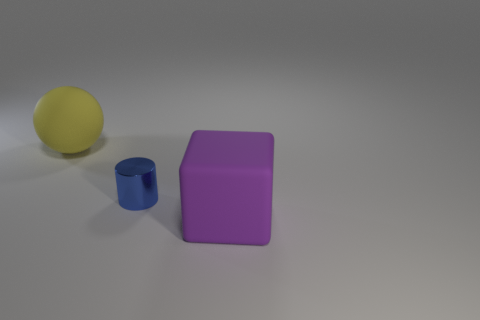Add 1 big purple objects. How many objects exist? 4 Subtract 1 blocks. How many blocks are left? 0 Subtract all spheres. How many objects are left? 2 Add 3 big purple matte cubes. How many big purple matte cubes exist? 4 Subtract 0 gray cubes. How many objects are left? 3 Subtract all cyan blocks. Subtract all cyan cylinders. How many blocks are left? 1 Subtract all red blocks. How many red cylinders are left? 0 Subtract all shiny cylinders. Subtract all balls. How many objects are left? 1 Add 2 blue metal cylinders. How many blue metal cylinders are left? 3 